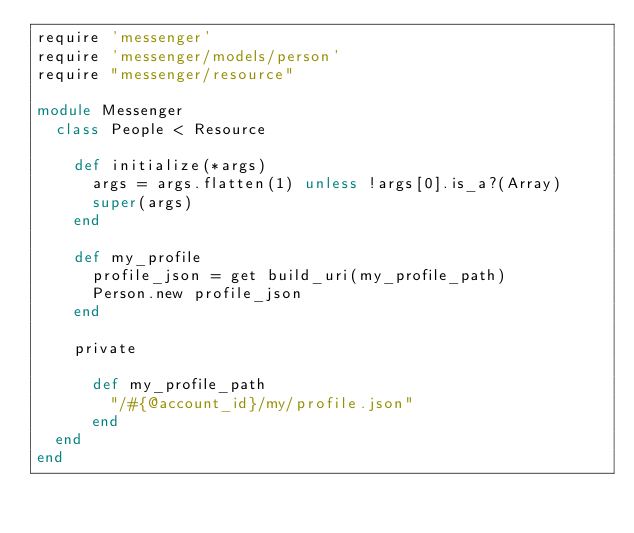Convert code to text. <code><loc_0><loc_0><loc_500><loc_500><_Ruby_>require 'messenger'
require 'messenger/models/person'
require "messenger/resource"

module Messenger
  class People < Resource

    def initialize(*args)
      args = args.flatten(1) unless !args[0].is_a?(Array)
      super(args)
    end

    def my_profile
      profile_json = get build_uri(my_profile_path)
      Person.new profile_json
    end

    private

      def my_profile_path
        "/#{@account_id}/my/profile.json"
      end
  end
end</code> 